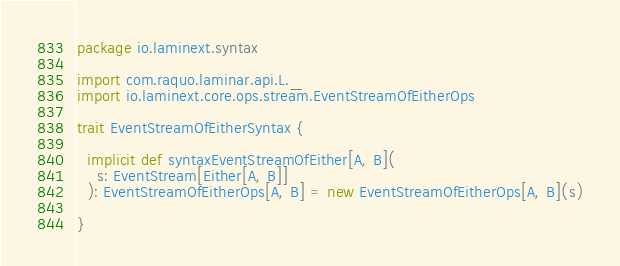Convert code to text. <code><loc_0><loc_0><loc_500><loc_500><_Scala_>package io.laminext.syntax

import com.raquo.laminar.api.L._
import io.laminext.core.ops.stream.EventStreamOfEitherOps

trait EventStreamOfEitherSyntax {

  implicit def syntaxEventStreamOfEither[A, B](
    s: EventStream[Either[A, B]]
  ): EventStreamOfEitherOps[A, B] = new EventStreamOfEitherOps[A, B](s)

}
</code> 